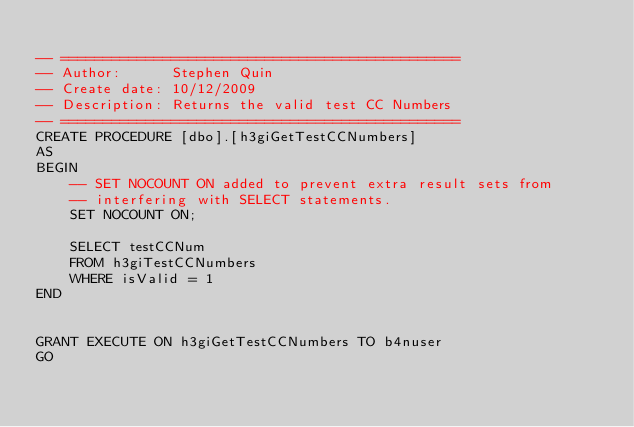Convert code to text. <code><loc_0><loc_0><loc_500><loc_500><_SQL_>
-- ===============================================
-- Author:		Stephen Quin
-- Create date: 10/12/2009
-- Description:	Returns the valid test CC Numbers
-- ===============================================
CREATE PROCEDURE [dbo].[h3giGetTestCCNumbers]
AS
BEGIN
	-- SET NOCOUNT ON added to prevent extra result sets from
	-- interfering with SELECT statements.
	SET NOCOUNT ON;

	SELECT testCCNum
	FROM h3giTestCCNumbers
	WHERE isValid = 1
END


GRANT EXECUTE ON h3giGetTestCCNumbers TO b4nuser
GO
</code> 